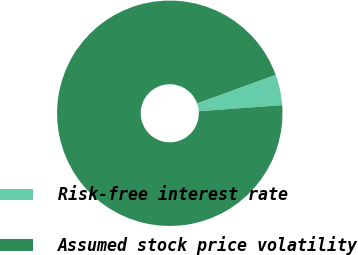<chart> <loc_0><loc_0><loc_500><loc_500><pie_chart><fcel>Risk-free interest rate<fcel>Assumed stock price volatility<nl><fcel>4.4%<fcel>95.6%<nl></chart> 